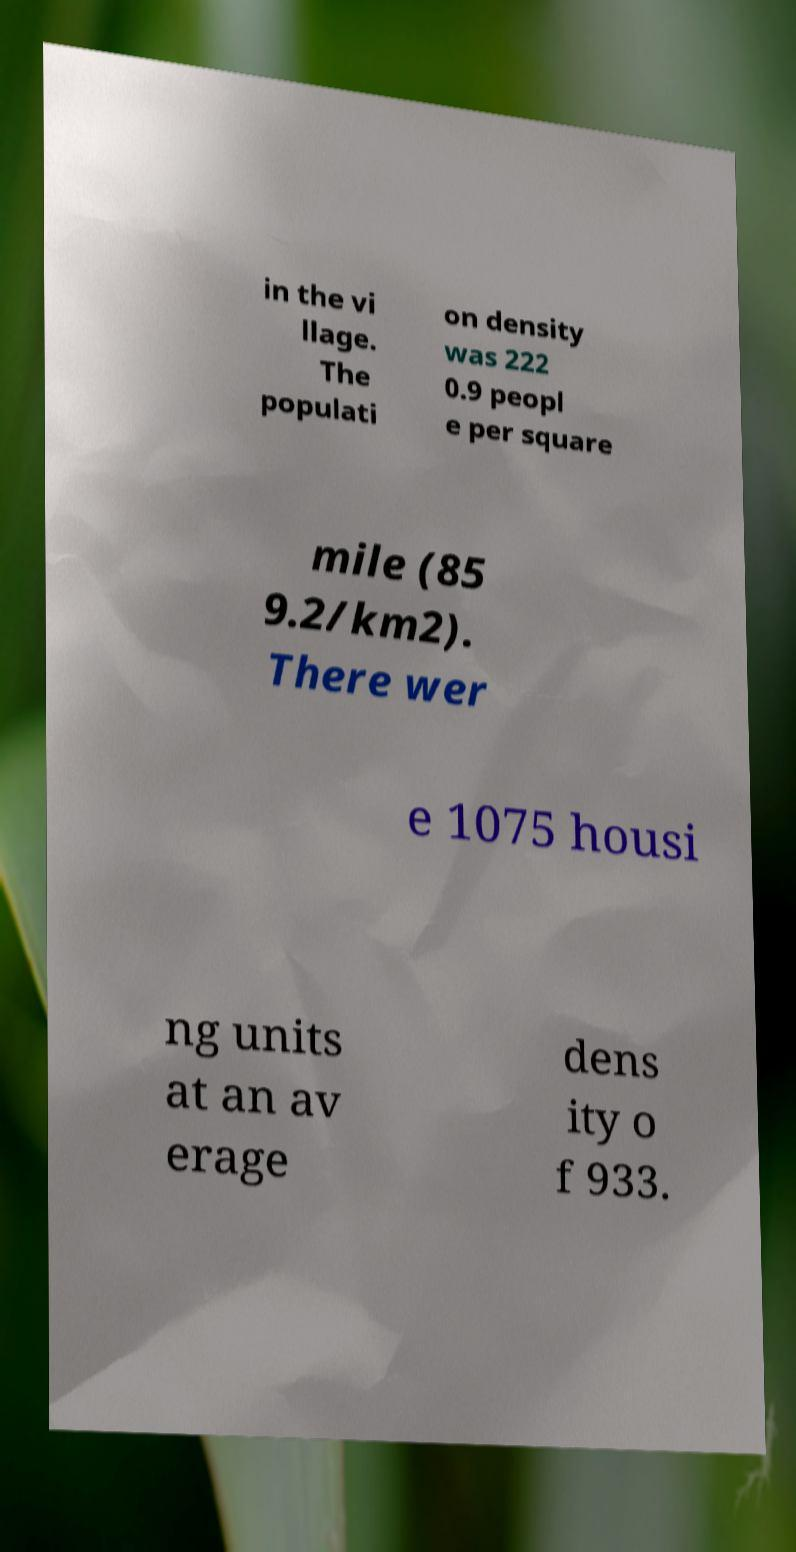I need the written content from this picture converted into text. Can you do that? in the vi llage. The populati on density was 222 0.9 peopl e per square mile (85 9.2/km2). There wer e 1075 housi ng units at an av erage dens ity o f 933. 